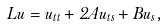Convert formula to latex. <formula><loc_0><loc_0><loc_500><loc_500>L u = u _ { t t } + 2 A u _ { t s } + B u _ { s } ,</formula> 